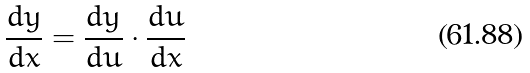<formula> <loc_0><loc_0><loc_500><loc_500>\frac { d y } { d x } = \frac { d y } { d u } \cdot \frac { d u } { d x }</formula> 